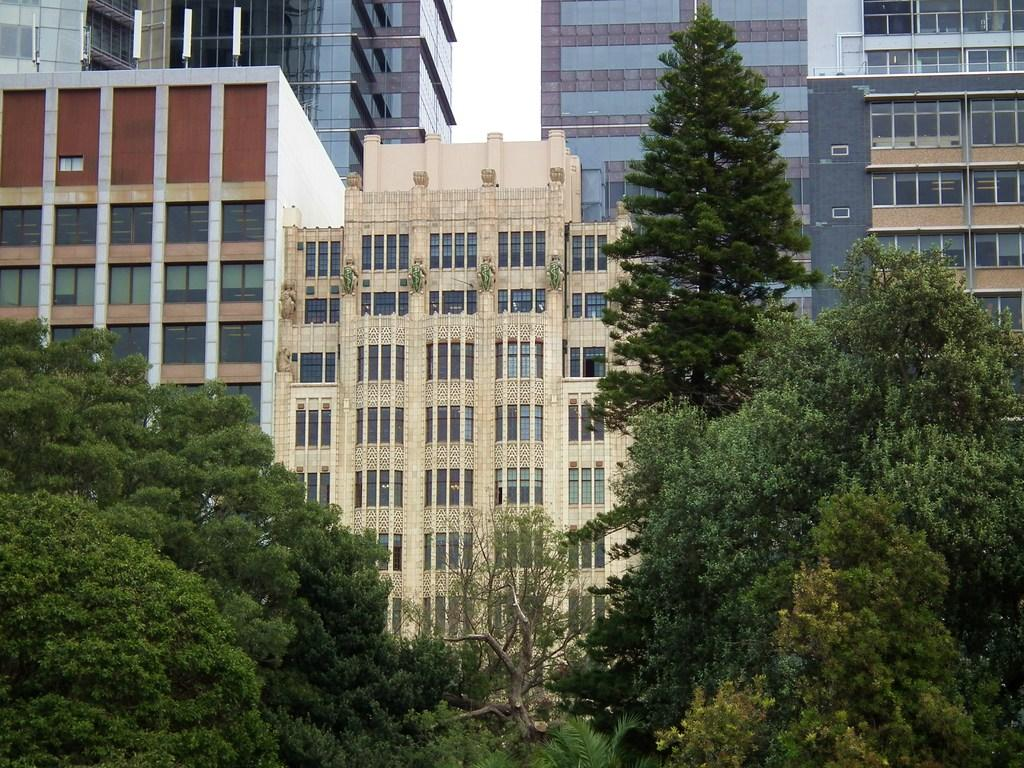What can be seen in the background of the image? In the background of the image, there is sky visible, as well as buildings and windows. What type of vegetation is present at the bottom portion of the image? Trees are present at the bottom portion of the image. Can you touch the coat that is hanging on the tree in the image? There is no coat hanging on a tree in the image; it only features sky, buildings, windows, and trees. 